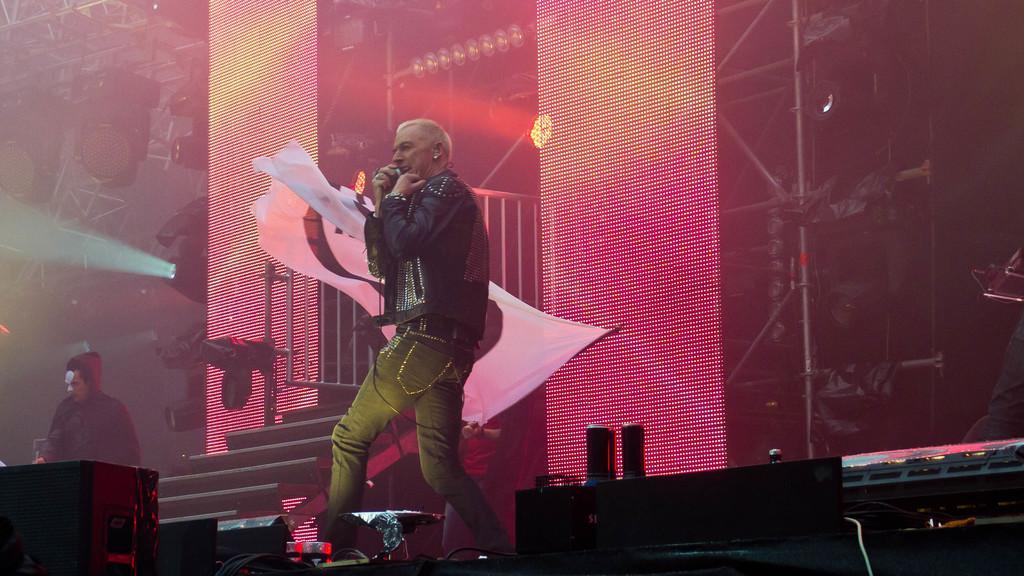Can you describe this image briefly? In this image I can see three persons are standing where in the front I can see one is holding a mic and in the background I can see one is holding a white colour flag. On the bottom side of this image I can see few black colour things and wires. In the background I can see number of lights and number of poles. 